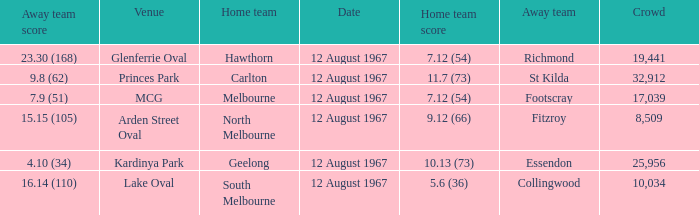What is the date of the game between Melbourne and Footscray? 12 August 1967. 